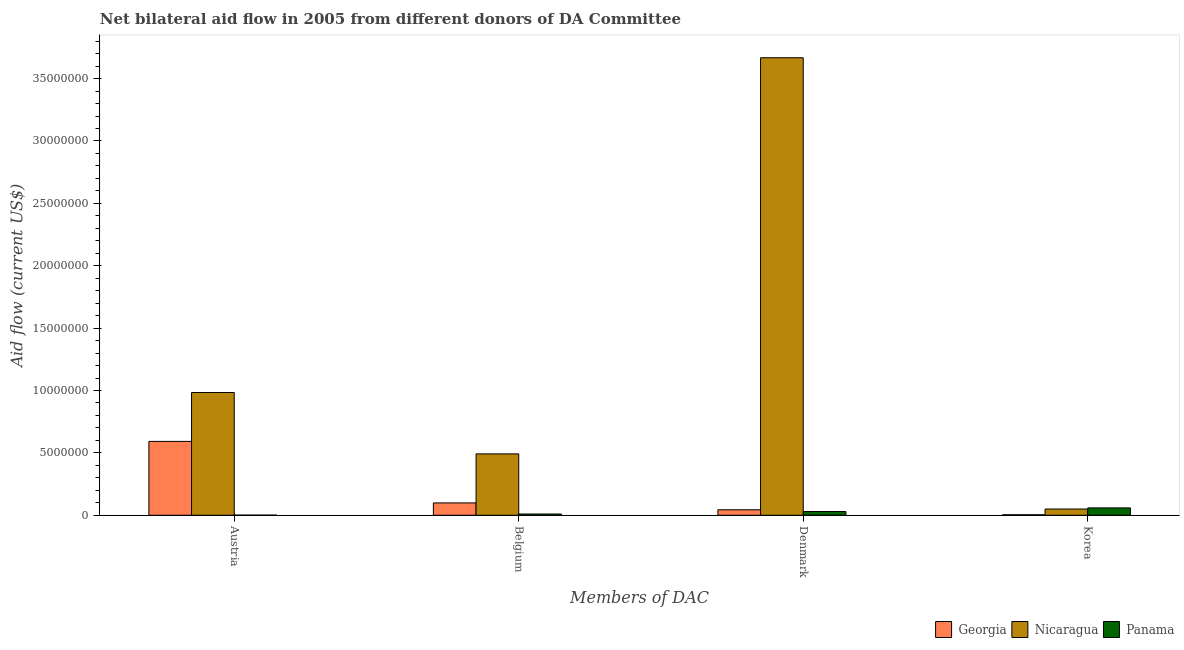Are the number of bars per tick equal to the number of legend labels?
Offer a terse response. Yes. What is the amount of aid given by belgium in Panama?
Your response must be concise. 1.00e+05. Across all countries, what is the maximum amount of aid given by belgium?
Your answer should be compact. 4.92e+06. Across all countries, what is the minimum amount of aid given by belgium?
Offer a very short reply. 1.00e+05. In which country was the amount of aid given by denmark maximum?
Offer a very short reply. Nicaragua. In which country was the amount of aid given by belgium minimum?
Your response must be concise. Panama. What is the total amount of aid given by denmark in the graph?
Ensure brevity in your answer.  3.74e+07. What is the difference between the amount of aid given by belgium in Panama and that in Georgia?
Keep it short and to the point. -8.90e+05. What is the difference between the amount of aid given by denmark in Panama and the amount of aid given by korea in Nicaragua?
Provide a succinct answer. -2.00e+05. What is the average amount of aid given by denmark per country?
Provide a short and direct response. 1.25e+07. What is the difference between the amount of aid given by denmark and amount of aid given by austria in Panama?
Offer a terse response. 2.90e+05. What is the ratio of the amount of aid given by korea in Panama to that in Georgia?
Give a very brief answer. 14.75. What is the difference between the highest and the second highest amount of aid given by denmark?
Your response must be concise. 3.62e+07. What is the difference between the highest and the lowest amount of aid given by denmark?
Your response must be concise. 3.64e+07. In how many countries, is the amount of aid given by austria greater than the average amount of aid given by austria taken over all countries?
Provide a short and direct response. 2. Is it the case that in every country, the sum of the amount of aid given by denmark and amount of aid given by korea is greater than the sum of amount of aid given by austria and amount of aid given by belgium?
Offer a very short reply. No. What does the 3rd bar from the left in Korea represents?
Offer a very short reply. Panama. What does the 1st bar from the right in Korea represents?
Provide a short and direct response. Panama. How many bars are there?
Offer a very short reply. 12. Are all the bars in the graph horizontal?
Keep it short and to the point. No. How many countries are there in the graph?
Offer a terse response. 3. Are the values on the major ticks of Y-axis written in scientific E-notation?
Provide a succinct answer. No. How many legend labels are there?
Give a very brief answer. 3. What is the title of the graph?
Offer a terse response. Net bilateral aid flow in 2005 from different donors of DA Committee. Does "Burkina Faso" appear as one of the legend labels in the graph?
Offer a terse response. No. What is the label or title of the X-axis?
Your answer should be very brief. Members of DAC. What is the Aid flow (current US$) in Georgia in Austria?
Offer a terse response. 5.92e+06. What is the Aid flow (current US$) in Nicaragua in Austria?
Provide a succinct answer. 9.84e+06. What is the Aid flow (current US$) of Georgia in Belgium?
Your response must be concise. 9.90e+05. What is the Aid flow (current US$) of Nicaragua in Belgium?
Give a very brief answer. 4.92e+06. What is the Aid flow (current US$) of Georgia in Denmark?
Your answer should be very brief. 4.40e+05. What is the Aid flow (current US$) of Nicaragua in Denmark?
Make the answer very short. 3.67e+07. What is the Aid flow (current US$) of Panama in Denmark?
Your answer should be very brief. 3.00e+05. What is the Aid flow (current US$) of Georgia in Korea?
Ensure brevity in your answer.  4.00e+04. What is the Aid flow (current US$) of Nicaragua in Korea?
Provide a short and direct response. 5.00e+05. What is the Aid flow (current US$) of Panama in Korea?
Offer a terse response. 5.90e+05. Across all Members of DAC, what is the maximum Aid flow (current US$) of Georgia?
Your response must be concise. 5.92e+06. Across all Members of DAC, what is the maximum Aid flow (current US$) in Nicaragua?
Your response must be concise. 3.67e+07. Across all Members of DAC, what is the maximum Aid flow (current US$) in Panama?
Offer a terse response. 5.90e+05. Across all Members of DAC, what is the minimum Aid flow (current US$) in Georgia?
Offer a very short reply. 4.00e+04. What is the total Aid flow (current US$) in Georgia in the graph?
Keep it short and to the point. 7.39e+06. What is the total Aid flow (current US$) of Nicaragua in the graph?
Provide a short and direct response. 5.19e+07. What is the difference between the Aid flow (current US$) of Georgia in Austria and that in Belgium?
Your answer should be compact. 4.93e+06. What is the difference between the Aid flow (current US$) in Nicaragua in Austria and that in Belgium?
Provide a short and direct response. 4.92e+06. What is the difference between the Aid flow (current US$) in Panama in Austria and that in Belgium?
Keep it short and to the point. -9.00e+04. What is the difference between the Aid flow (current US$) of Georgia in Austria and that in Denmark?
Your response must be concise. 5.48e+06. What is the difference between the Aid flow (current US$) of Nicaragua in Austria and that in Denmark?
Keep it short and to the point. -2.68e+07. What is the difference between the Aid flow (current US$) in Panama in Austria and that in Denmark?
Keep it short and to the point. -2.90e+05. What is the difference between the Aid flow (current US$) of Georgia in Austria and that in Korea?
Offer a very short reply. 5.88e+06. What is the difference between the Aid flow (current US$) of Nicaragua in Austria and that in Korea?
Offer a very short reply. 9.34e+06. What is the difference between the Aid flow (current US$) of Panama in Austria and that in Korea?
Your response must be concise. -5.80e+05. What is the difference between the Aid flow (current US$) in Nicaragua in Belgium and that in Denmark?
Keep it short and to the point. -3.18e+07. What is the difference between the Aid flow (current US$) of Panama in Belgium and that in Denmark?
Offer a very short reply. -2.00e+05. What is the difference between the Aid flow (current US$) in Georgia in Belgium and that in Korea?
Keep it short and to the point. 9.50e+05. What is the difference between the Aid flow (current US$) in Nicaragua in Belgium and that in Korea?
Ensure brevity in your answer.  4.42e+06. What is the difference between the Aid flow (current US$) of Panama in Belgium and that in Korea?
Provide a succinct answer. -4.90e+05. What is the difference between the Aid flow (current US$) in Georgia in Denmark and that in Korea?
Your response must be concise. 4.00e+05. What is the difference between the Aid flow (current US$) in Nicaragua in Denmark and that in Korea?
Ensure brevity in your answer.  3.62e+07. What is the difference between the Aid flow (current US$) of Panama in Denmark and that in Korea?
Offer a very short reply. -2.90e+05. What is the difference between the Aid flow (current US$) in Georgia in Austria and the Aid flow (current US$) in Panama in Belgium?
Provide a succinct answer. 5.82e+06. What is the difference between the Aid flow (current US$) in Nicaragua in Austria and the Aid flow (current US$) in Panama in Belgium?
Keep it short and to the point. 9.74e+06. What is the difference between the Aid flow (current US$) in Georgia in Austria and the Aid flow (current US$) in Nicaragua in Denmark?
Offer a very short reply. -3.08e+07. What is the difference between the Aid flow (current US$) of Georgia in Austria and the Aid flow (current US$) of Panama in Denmark?
Offer a very short reply. 5.62e+06. What is the difference between the Aid flow (current US$) in Nicaragua in Austria and the Aid flow (current US$) in Panama in Denmark?
Give a very brief answer. 9.54e+06. What is the difference between the Aid flow (current US$) in Georgia in Austria and the Aid flow (current US$) in Nicaragua in Korea?
Keep it short and to the point. 5.42e+06. What is the difference between the Aid flow (current US$) in Georgia in Austria and the Aid flow (current US$) in Panama in Korea?
Provide a short and direct response. 5.33e+06. What is the difference between the Aid flow (current US$) of Nicaragua in Austria and the Aid flow (current US$) of Panama in Korea?
Provide a short and direct response. 9.25e+06. What is the difference between the Aid flow (current US$) of Georgia in Belgium and the Aid flow (current US$) of Nicaragua in Denmark?
Provide a short and direct response. -3.57e+07. What is the difference between the Aid flow (current US$) in Georgia in Belgium and the Aid flow (current US$) in Panama in Denmark?
Give a very brief answer. 6.90e+05. What is the difference between the Aid flow (current US$) of Nicaragua in Belgium and the Aid flow (current US$) of Panama in Denmark?
Your answer should be compact. 4.62e+06. What is the difference between the Aid flow (current US$) in Nicaragua in Belgium and the Aid flow (current US$) in Panama in Korea?
Your response must be concise. 4.33e+06. What is the difference between the Aid flow (current US$) of Georgia in Denmark and the Aid flow (current US$) of Nicaragua in Korea?
Your response must be concise. -6.00e+04. What is the difference between the Aid flow (current US$) of Georgia in Denmark and the Aid flow (current US$) of Panama in Korea?
Make the answer very short. -1.50e+05. What is the difference between the Aid flow (current US$) of Nicaragua in Denmark and the Aid flow (current US$) of Panama in Korea?
Your answer should be very brief. 3.61e+07. What is the average Aid flow (current US$) in Georgia per Members of DAC?
Provide a short and direct response. 1.85e+06. What is the average Aid flow (current US$) in Nicaragua per Members of DAC?
Ensure brevity in your answer.  1.30e+07. What is the average Aid flow (current US$) of Panama per Members of DAC?
Your answer should be compact. 2.50e+05. What is the difference between the Aid flow (current US$) in Georgia and Aid flow (current US$) in Nicaragua in Austria?
Ensure brevity in your answer.  -3.92e+06. What is the difference between the Aid flow (current US$) in Georgia and Aid flow (current US$) in Panama in Austria?
Your response must be concise. 5.91e+06. What is the difference between the Aid flow (current US$) in Nicaragua and Aid flow (current US$) in Panama in Austria?
Your answer should be very brief. 9.83e+06. What is the difference between the Aid flow (current US$) in Georgia and Aid flow (current US$) in Nicaragua in Belgium?
Give a very brief answer. -3.93e+06. What is the difference between the Aid flow (current US$) in Georgia and Aid flow (current US$) in Panama in Belgium?
Give a very brief answer. 8.90e+05. What is the difference between the Aid flow (current US$) in Nicaragua and Aid flow (current US$) in Panama in Belgium?
Your answer should be very brief. 4.82e+06. What is the difference between the Aid flow (current US$) in Georgia and Aid flow (current US$) in Nicaragua in Denmark?
Provide a short and direct response. -3.62e+07. What is the difference between the Aid flow (current US$) in Georgia and Aid flow (current US$) in Panama in Denmark?
Keep it short and to the point. 1.40e+05. What is the difference between the Aid flow (current US$) of Nicaragua and Aid flow (current US$) of Panama in Denmark?
Ensure brevity in your answer.  3.64e+07. What is the difference between the Aid flow (current US$) of Georgia and Aid flow (current US$) of Nicaragua in Korea?
Offer a very short reply. -4.60e+05. What is the difference between the Aid flow (current US$) in Georgia and Aid flow (current US$) in Panama in Korea?
Keep it short and to the point. -5.50e+05. What is the ratio of the Aid flow (current US$) of Georgia in Austria to that in Belgium?
Your answer should be very brief. 5.98. What is the ratio of the Aid flow (current US$) in Nicaragua in Austria to that in Belgium?
Provide a succinct answer. 2. What is the ratio of the Aid flow (current US$) in Panama in Austria to that in Belgium?
Your answer should be compact. 0.1. What is the ratio of the Aid flow (current US$) in Georgia in Austria to that in Denmark?
Your response must be concise. 13.45. What is the ratio of the Aid flow (current US$) in Nicaragua in Austria to that in Denmark?
Provide a succinct answer. 0.27. What is the ratio of the Aid flow (current US$) in Georgia in Austria to that in Korea?
Offer a terse response. 148. What is the ratio of the Aid flow (current US$) of Nicaragua in Austria to that in Korea?
Offer a very short reply. 19.68. What is the ratio of the Aid flow (current US$) of Panama in Austria to that in Korea?
Provide a short and direct response. 0.02. What is the ratio of the Aid flow (current US$) in Georgia in Belgium to that in Denmark?
Give a very brief answer. 2.25. What is the ratio of the Aid flow (current US$) of Nicaragua in Belgium to that in Denmark?
Keep it short and to the point. 0.13. What is the ratio of the Aid flow (current US$) of Panama in Belgium to that in Denmark?
Offer a very short reply. 0.33. What is the ratio of the Aid flow (current US$) of Georgia in Belgium to that in Korea?
Provide a succinct answer. 24.75. What is the ratio of the Aid flow (current US$) in Nicaragua in Belgium to that in Korea?
Provide a short and direct response. 9.84. What is the ratio of the Aid flow (current US$) of Panama in Belgium to that in Korea?
Provide a succinct answer. 0.17. What is the ratio of the Aid flow (current US$) of Georgia in Denmark to that in Korea?
Offer a terse response. 11. What is the ratio of the Aid flow (current US$) in Nicaragua in Denmark to that in Korea?
Offer a terse response. 73.34. What is the ratio of the Aid flow (current US$) in Panama in Denmark to that in Korea?
Offer a terse response. 0.51. What is the difference between the highest and the second highest Aid flow (current US$) of Georgia?
Keep it short and to the point. 4.93e+06. What is the difference between the highest and the second highest Aid flow (current US$) in Nicaragua?
Provide a succinct answer. 2.68e+07. What is the difference between the highest and the second highest Aid flow (current US$) of Panama?
Provide a succinct answer. 2.90e+05. What is the difference between the highest and the lowest Aid flow (current US$) in Georgia?
Keep it short and to the point. 5.88e+06. What is the difference between the highest and the lowest Aid flow (current US$) of Nicaragua?
Make the answer very short. 3.62e+07. What is the difference between the highest and the lowest Aid flow (current US$) in Panama?
Your response must be concise. 5.80e+05. 